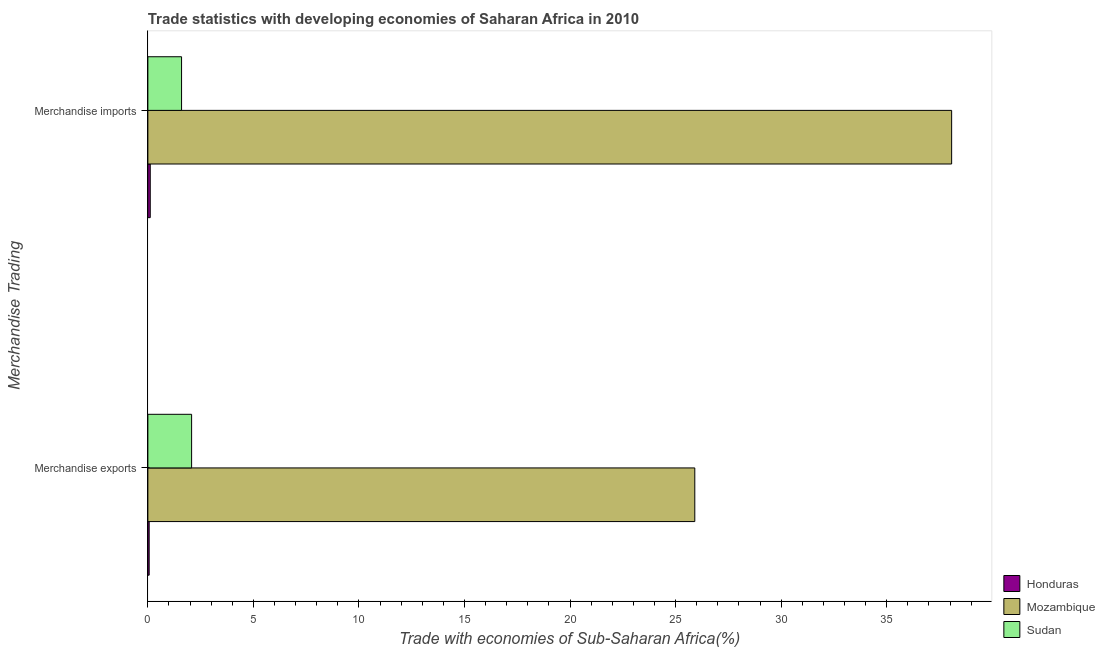How many different coloured bars are there?
Make the answer very short. 3. How many groups of bars are there?
Offer a terse response. 2. What is the label of the 2nd group of bars from the top?
Offer a terse response. Merchandise exports. What is the merchandise exports in Mozambique?
Your answer should be compact. 25.91. Across all countries, what is the maximum merchandise exports?
Offer a very short reply. 25.91. Across all countries, what is the minimum merchandise imports?
Offer a very short reply. 0.11. In which country was the merchandise imports maximum?
Ensure brevity in your answer.  Mozambique. In which country was the merchandise imports minimum?
Ensure brevity in your answer.  Honduras. What is the total merchandise imports in the graph?
Keep it short and to the point. 39.79. What is the difference between the merchandise exports in Mozambique and that in Sudan?
Make the answer very short. 23.84. What is the difference between the merchandise exports in Mozambique and the merchandise imports in Honduras?
Offer a very short reply. 25.8. What is the average merchandise exports per country?
Make the answer very short. 9.35. What is the difference between the merchandise imports and merchandise exports in Mozambique?
Your answer should be compact. 12.17. What is the ratio of the merchandise imports in Mozambique to that in Honduras?
Your response must be concise. 338.22. What does the 1st bar from the top in Merchandise exports represents?
Your response must be concise. Sudan. What does the 1st bar from the bottom in Merchandise imports represents?
Provide a short and direct response. Honduras. Are all the bars in the graph horizontal?
Make the answer very short. Yes. What is the difference between two consecutive major ticks on the X-axis?
Your answer should be very brief. 5. Are the values on the major ticks of X-axis written in scientific E-notation?
Give a very brief answer. No. Does the graph contain grids?
Give a very brief answer. No. How many legend labels are there?
Give a very brief answer. 3. What is the title of the graph?
Offer a very short reply. Trade statistics with developing economies of Saharan Africa in 2010. Does "Colombia" appear as one of the legend labels in the graph?
Give a very brief answer. No. What is the label or title of the X-axis?
Offer a very short reply. Trade with economies of Sub-Saharan Africa(%). What is the label or title of the Y-axis?
Provide a short and direct response. Merchandise Trading. What is the Trade with economies of Sub-Saharan Africa(%) in Honduras in Merchandise exports?
Provide a succinct answer. 0.06. What is the Trade with economies of Sub-Saharan Africa(%) of Mozambique in Merchandise exports?
Your answer should be very brief. 25.91. What is the Trade with economies of Sub-Saharan Africa(%) in Sudan in Merchandise exports?
Your answer should be very brief. 2.07. What is the Trade with economies of Sub-Saharan Africa(%) of Honduras in Merchandise imports?
Give a very brief answer. 0.11. What is the Trade with economies of Sub-Saharan Africa(%) of Mozambique in Merchandise imports?
Offer a terse response. 38.08. What is the Trade with economies of Sub-Saharan Africa(%) in Sudan in Merchandise imports?
Your answer should be compact. 1.6. Across all Merchandise Trading, what is the maximum Trade with economies of Sub-Saharan Africa(%) in Honduras?
Provide a short and direct response. 0.11. Across all Merchandise Trading, what is the maximum Trade with economies of Sub-Saharan Africa(%) of Mozambique?
Your answer should be compact. 38.08. Across all Merchandise Trading, what is the maximum Trade with economies of Sub-Saharan Africa(%) of Sudan?
Keep it short and to the point. 2.07. Across all Merchandise Trading, what is the minimum Trade with economies of Sub-Saharan Africa(%) in Honduras?
Your answer should be very brief. 0.06. Across all Merchandise Trading, what is the minimum Trade with economies of Sub-Saharan Africa(%) in Mozambique?
Your answer should be very brief. 25.91. Across all Merchandise Trading, what is the minimum Trade with economies of Sub-Saharan Africa(%) in Sudan?
Your answer should be very brief. 1.6. What is the total Trade with economies of Sub-Saharan Africa(%) of Honduras in the graph?
Offer a very short reply. 0.17. What is the total Trade with economies of Sub-Saharan Africa(%) of Mozambique in the graph?
Ensure brevity in your answer.  63.99. What is the total Trade with economies of Sub-Saharan Africa(%) of Sudan in the graph?
Give a very brief answer. 3.67. What is the difference between the Trade with economies of Sub-Saharan Africa(%) in Honduras in Merchandise exports and that in Merchandise imports?
Your answer should be compact. -0.05. What is the difference between the Trade with economies of Sub-Saharan Africa(%) in Mozambique in Merchandise exports and that in Merchandise imports?
Your answer should be compact. -12.17. What is the difference between the Trade with economies of Sub-Saharan Africa(%) of Sudan in Merchandise exports and that in Merchandise imports?
Keep it short and to the point. 0.48. What is the difference between the Trade with economies of Sub-Saharan Africa(%) of Honduras in Merchandise exports and the Trade with economies of Sub-Saharan Africa(%) of Mozambique in Merchandise imports?
Offer a terse response. -38.02. What is the difference between the Trade with economies of Sub-Saharan Africa(%) in Honduras in Merchandise exports and the Trade with economies of Sub-Saharan Africa(%) in Sudan in Merchandise imports?
Keep it short and to the point. -1.53. What is the difference between the Trade with economies of Sub-Saharan Africa(%) in Mozambique in Merchandise exports and the Trade with economies of Sub-Saharan Africa(%) in Sudan in Merchandise imports?
Provide a short and direct response. 24.31. What is the average Trade with economies of Sub-Saharan Africa(%) of Honduras per Merchandise Trading?
Provide a short and direct response. 0.09. What is the average Trade with economies of Sub-Saharan Africa(%) in Mozambique per Merchandise Trading?
Provide a short and direct response. 31.99. What is the average Trade with economies of Sub-Saharan Africa(%) in Sudan per Merchandise Trading?
Ensure brevity in your answer.  1.83. What is the difference between the Trade with economies of Sub-Saharan Africa(%) of Honduras and Trade with economies of Sub-Saharan Africa(%) of Mozambique in Merchandise exports?
Keep it short and to the point. -25.85. What is the difference between the Trade with economies of Sub-Saharan Africa(%) in Honduras and Trade with economies of Sub-Saharan Africa(%) in Sudan in Merchandise exports?
Make the answer very short. -2.01. What is the difference between the Trade with economies of Sub-Saharan Africa(%) in Mozambique and Trade with economies of Sub-Saharan Africa(%) in Sudan in Merchandise exports?
Offer a very short reply. 23.84. What is the difference between the Trade with economies of Sub-Saharan Africa(%) of Honduras and Trade with economies of Sub-Saharan Africa(%) of Mozambique in Merchandise imports?
Offer a very short reply. -37.97. What is the difference between the Trade with economies of Sub-Saharan Africa(%) of Honduras and Trade with economies of Sub-Saharan Africa(%) of Sudan in Merchandise imports?
Give a very brief answer. -1.48. What is the difference between the Trade with economies of Sub-Saharan Africa(%) of Mozambique and Trade with economies of Sub-Saharan Africa(%) of Sudan in Merchandise imports?
Offer a very short reply. 36.48. What is the ratio of the Trade with economies of Sub-Saharan Africa(%) in Honduras in Merchandise exports to that in Merchandise imports?
Ensure brevity in your answer.  0.55. What is the ratio of the Trade with economies of Sub-Saharan Africa(%) of Mozambique in Merchandise exports to that in Merchandise imports?
Give a very brief answer. 0.68. What is the ratio of the Trade with economies of Sub-Saharan Africa(%) of Sudan in Merchandise exports to that in Merchandise imports?
Offer a terse response. 1.3. What is the difference between the highest and the second highest Trade with economies of Sub-Saharan Africa(%) in Honduras?
Your answer should be compact. 0.05. What is the difference between the highest and the second highest Trade with economies of Sub-Saharan Africa(%) in Mozambique?
Make the answer very short. 12.17. What is the difference between the highest and the second highest Trade with economies of Sub-Saharan Africa(%) in Sudan?
Offer a terse response. 0.48. What is the difference between the highest and the lowest Trade with economies of Sub-Saharan Africa(%) of Honduras?
Make the answer very short. 0.05. What is the difference between the highest and the lowest Trade with economies of Sub-Saharan Africa(%) of Mozambique?
Offer a terse response. 12.17. What is the difference between the highest and the lowest Trade with economies of Sub-Saharan Africa(%) in Sudan?
Your answer should be compact. 0.48. 